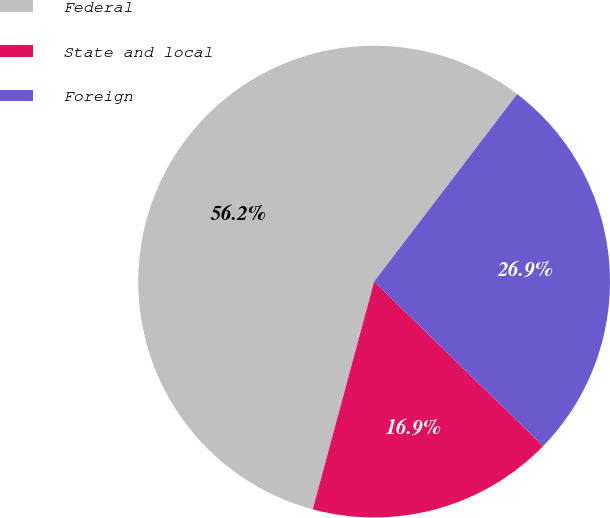<chart> <loc_0><loc_0><loc_500><loc_500><pie_chart><fcel>Federal<fcel>State and local<fcel>Foreign<nl><fcel>56.18%<fcel>16.91%<fcel>26.9%<nl></chart> 